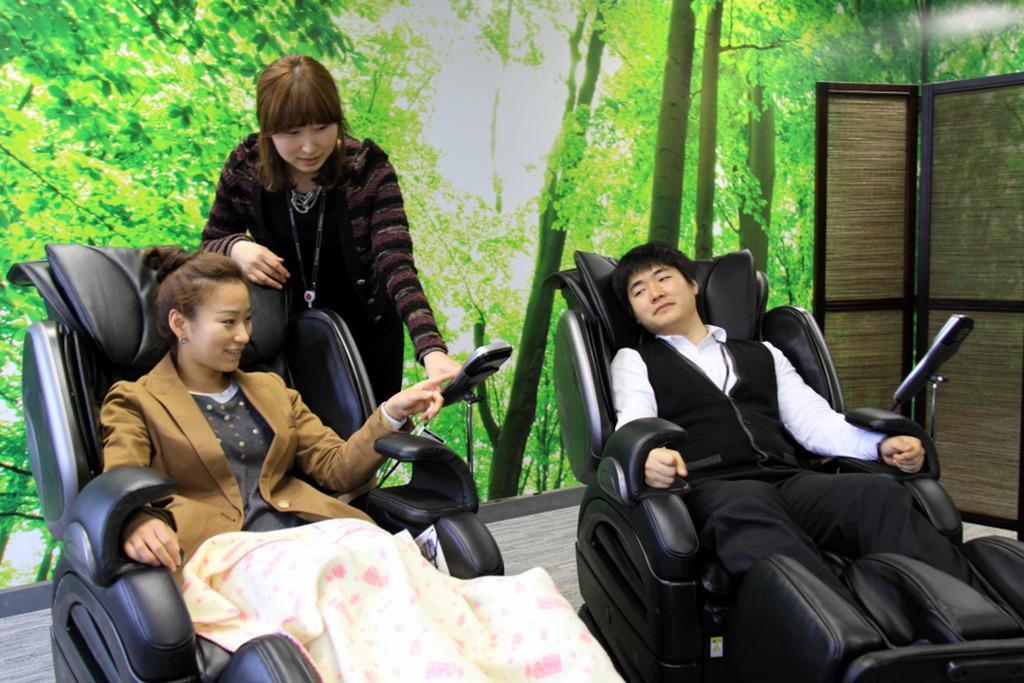What are the two persons in the image doing? The two persons in the image are sitting in massage chairs. Can you describe the woman in the image? There is a woman standing behind the two persons in the image. What is the color of the ground in the image? The ground is green in color. What type of mitten is the woman wearing in the image? There is no mitten present in the image. Can you hear the woman crying in the image? The image is silent, and there is no indication of the woman crying. 